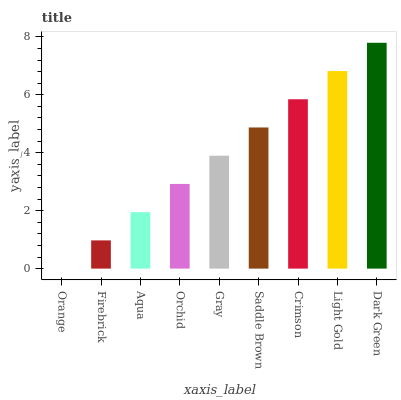Is Orange the minimum?
Answer yes or no. Yes. Is Dark Green the maximum?
Answer yes or no. Yes. Is Firebrick the minimum?
Answer yes or no. No. Is Firebrick the maximum?
Answer yes or no. No. Is Firebrick greater than Orange?
Answer yes or no. Yes. Is Orange less than Firebrick?
Answer yes or no. Yes. Is Orange greater than Firebrick?
Answer yes or no. No. Is Firebrick less than Orange?
Answer yes or no. No. Is Gray the high median?
Answer yes or no. Yes. Is Gray the low median?
Answer yes or no. Yes. Is Aqua the high median?
Answer yes or no. No. Is Dark Green the low median?
Answer yes or no. No. 